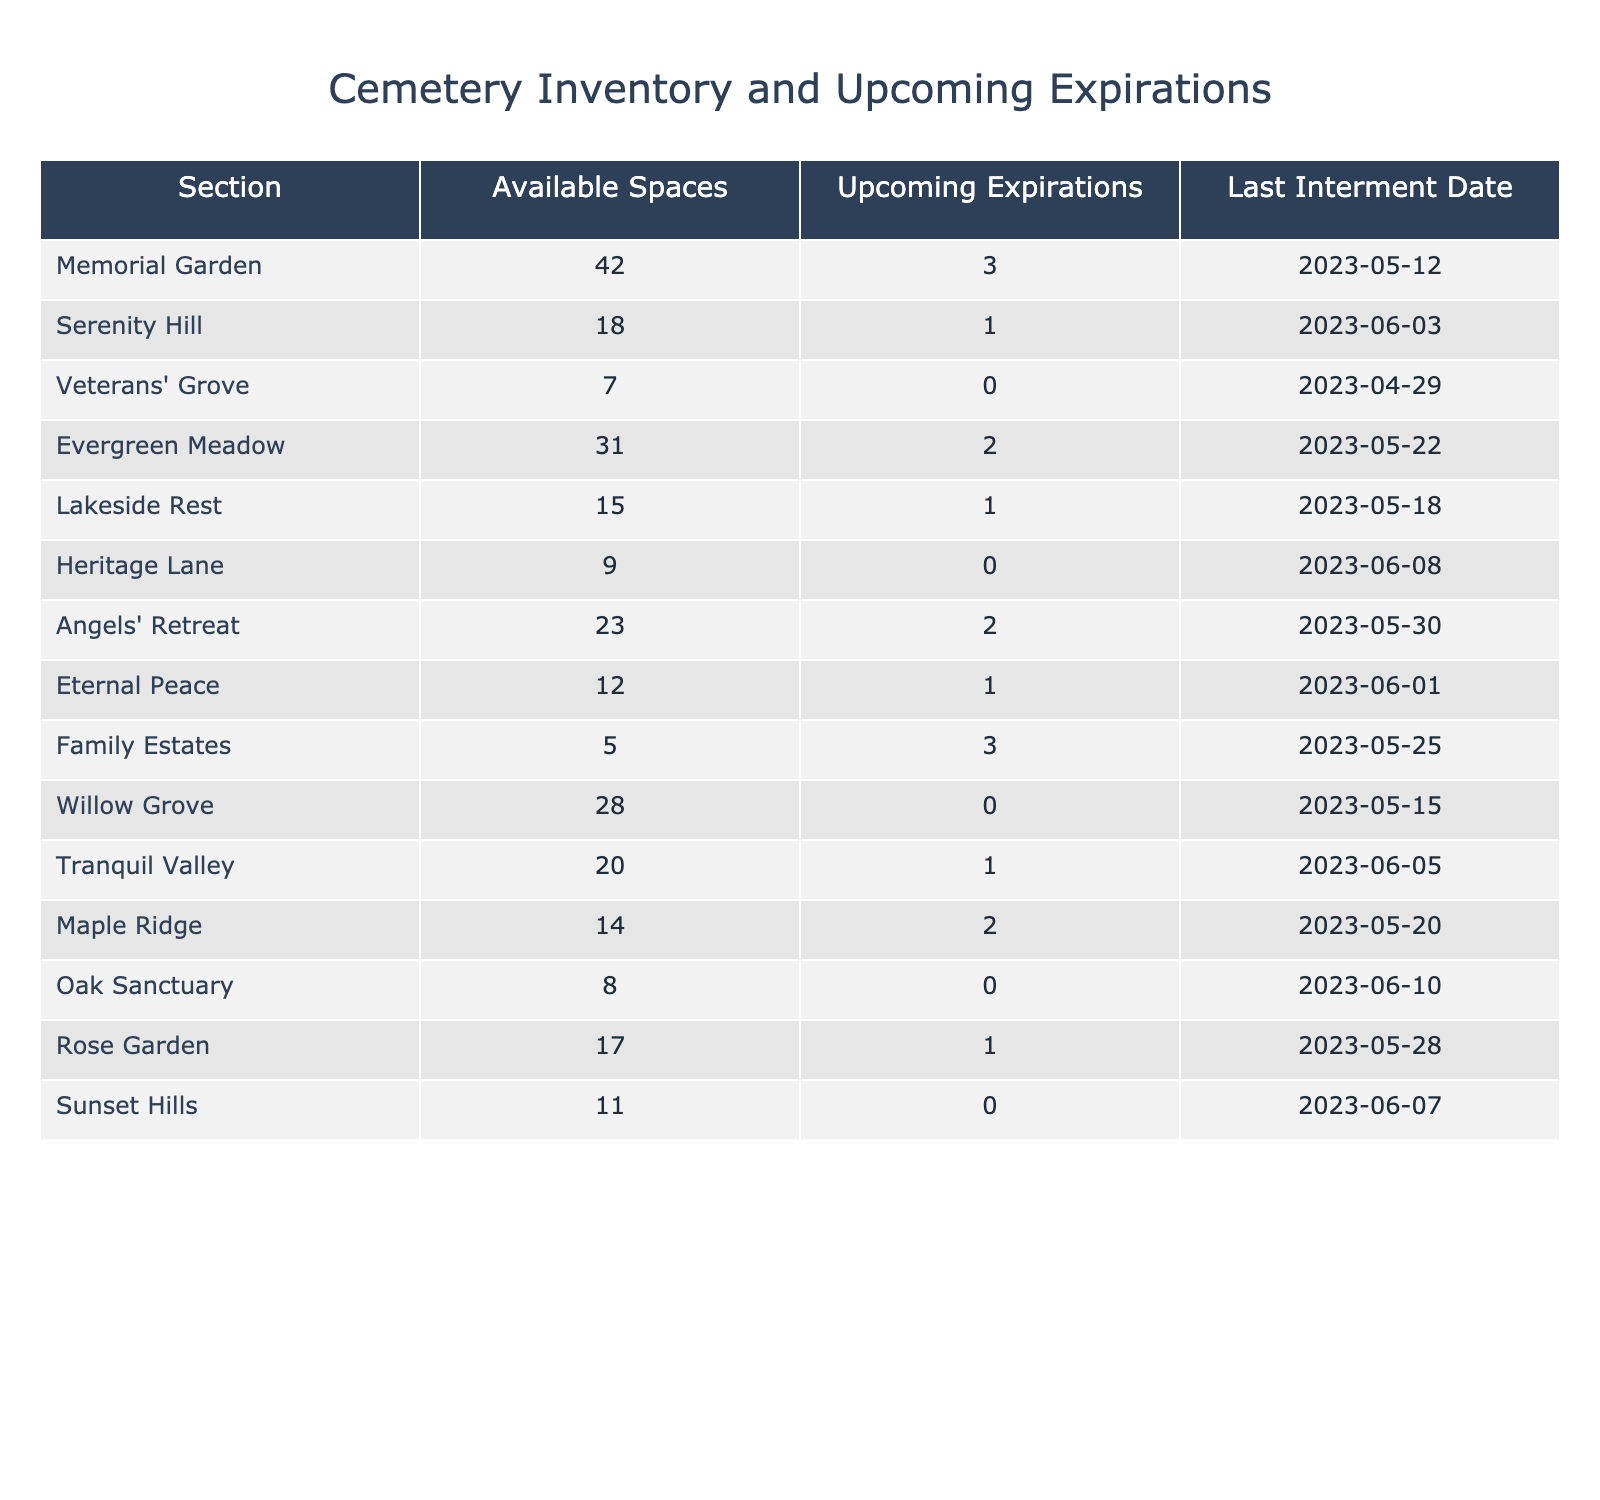What is the total number of available grave spaces across all sections? By adding the available spaces from all sections: 42 + 18 + 7 + 31 + 15 + 9 + 23 + 12 + 5 + 28 + 20 + 14 + 8 + 17 + 11 =  309
Answer: 309 How many sections have upcoming expirations? By checking the "Upcoming Expirations" column, the sections with > 0 expirations are Memorial Garden, Serenity Hill, Evergreen Meadow, Lakeside Rest, Angels' Retreat, Eternal Peace, Family Estates, and Tranquil Valley. There are 8 sections total.
Answer: 8 What section has the highest number of available spaces? Looking at the available spaces column, Memorial Garden has the highest number with 42 spaces available.
Answer: Memorial Garden Is there any section that has no available grave spaces? By inspecting the available spaces column, we can see that no sections have a value of 0, so the answer is no.
Answer: No What is the average number of available spaces per section? There are 15 sections in total and the total available spaces are 309. The average is calculated as 309 / 15 = 20.6.
Answer: 20.6 Which section has the most upcoming expirations? By checking the upcoming expirations column, Family Estates has the most with 3 upcoming expirations.
Answer: Family Estates Are any sections available for interment after the most recent interment date? The most recent interment date is 2023-06-10 from Oak Sanctuary. All sections have availability for future dates, so the answer is yes.
Answer: Yes If we combine the available spaces of Serenity Hill and Lakeside Rest, how many total available grave spaces do they have? Serenity Hill has 18 and Lakeside Rest has 15, so the total is 18 + 15 = 33.
Answer: 33 How many sections have exactly one upcoming expiration? The sections with one upcoming expiration are Serenity Hill, Lakeside Rest, Eternal Peace, and Tranquil Valley. This totals to 4 sections.
Answer: 4 What is the section with the oldest last interment date? From the last interment date column, the oldest date is 2023-04-29 from Veterans' Grove.
Answer: Veterans' Grove 